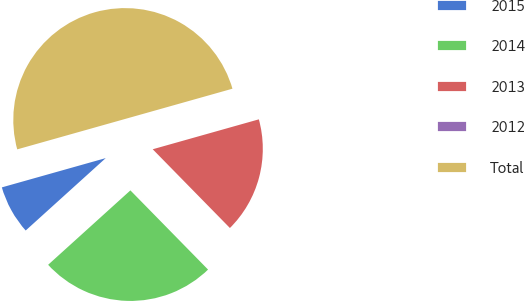<chart> <loc_0><loc_0><loc_500><loc_500><pie_chart><fcel>2015<fcel>2014<fcel>2013<fcel>2012<fcel>Total<nl><fcel>7.33%<fcel>25.64%<fcel>17.03%<fcel>0.0%<fcel>50.0%<nl></chart> 